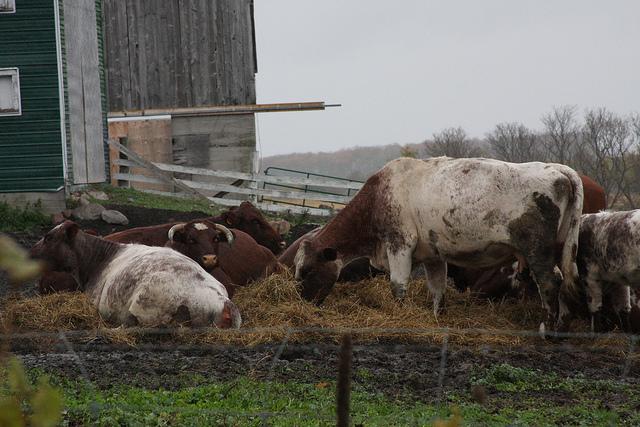What animal is this?
Quick response, please. Cow. What kind of animals are shown?
Quick response, please. Cows. What breed of horse might this be?
Give a very brief answer. Cow. Was this picture taken in a city?
Quick response, please. No. What is the cow eating?
Give a very brief answer. Hay. 